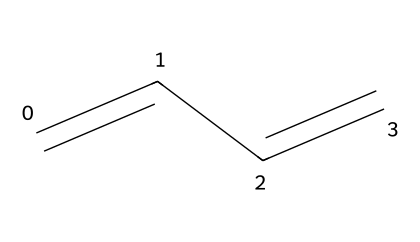What is the name of the chemical represented by the structure? The SMILES notation shows a linear arrangement of carbon atoms connected by double bonds, which corresponds to 1,3-butadiene, a common name for this compound.
Answer: 1,3-butadiene How many carbon atoms are in this compound? The SMILES representation includes four carbon atoms (C), evident from the starting 'C' followed by internal carbon connections.
Answer: 4 How many double bonds are present in this molecule? The structure features two double bonds between the carbon atoms, clearly depicted in the SMILES representation by the '=' signs.
Answer: 2 Is this compound saturated or unsaturated? The presence of double bonds indicates that the compound is unsaturated, as alkene families contain at least one double bond.
Answer: unsaturated What type of compound is butadiene classified as? Butadiene is classified as an aliphatic compound due to its open-chain structure without any cyclic components, fitting in the alkene family.
Answer: aliphatic How many hydrogen atoms are present in butadiene? For every carbon atom in an alkene, the formula is CnH2n, where n is the number of carbon atoms. For 4 carbon atoms, we calculate 2(4)=8 hydrogen atoms.
Answer: 6 What is the significance of butadiene in construction applications? Butadiene is significant because it is a vital monomer in the production of synthetic rubbers, vital for enhancing durability and elasticity in construction materials.
Answer: synthetic rubber 